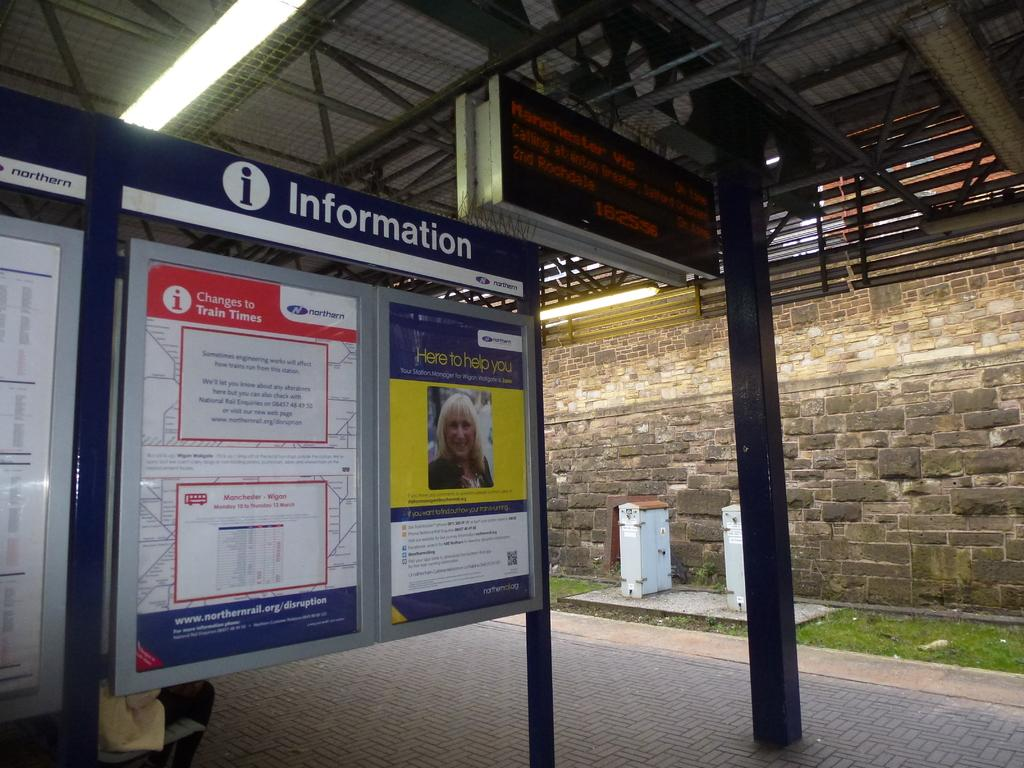<image>
Render a clear and concise summary of the photo. The board in the train station gives information. 